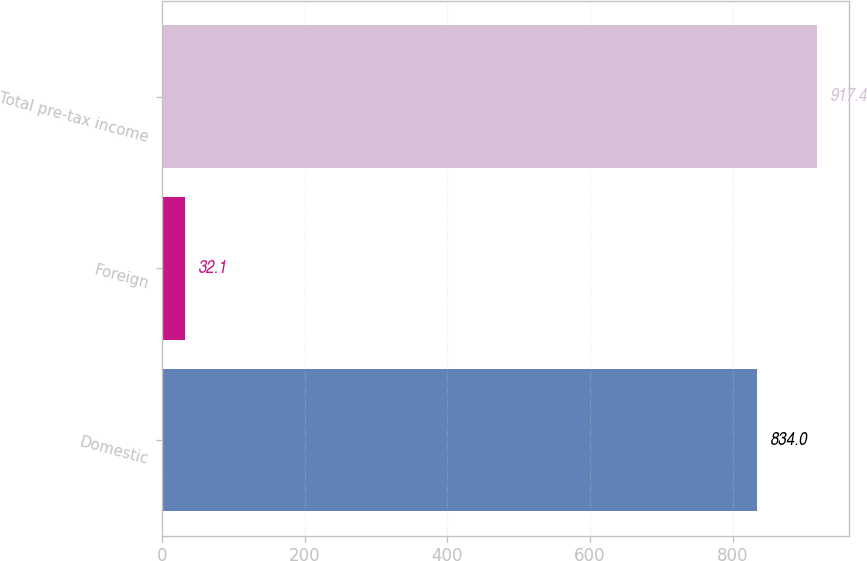Convert chart to OTSL. <chart><loc_0><loc_0><loc_500><loc_500><bar_chart><fcel>Domestic<fcel>Foreign<fcel>Total pre-tax income<nl><fcel>834<fcel>32.1<fcel>917.4<nl></chart> 